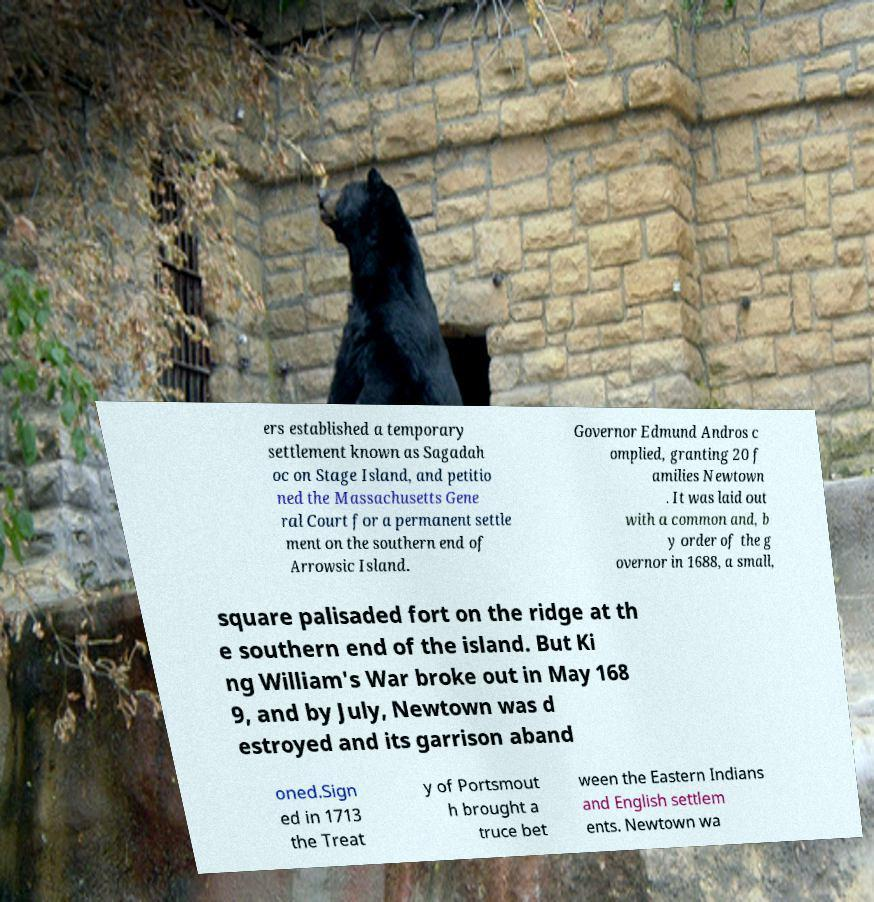For documentation purposes, I need the text within this image transcribed. Could you provide that? ers established a temporary settlement known as Sagadah oc on Stage Island, and petitio ned the Massachusetts Gene ral Court for a permanent settle ment on the southern end of Arrowsic Island. Governor Edmund Andros c omplied, granting 20 f amilies Newtown . It was laid out with a common and, b y order of the g overnor in 1688, a small, square palisaded fort on the ridge at th e southern end of the island. But Ki ng William's War broke out in May 168 9, and by July, Newtown was d estroyed and its garrison aband oned.Sign ed in 1713 the Treat y of Portsmout h brought a truce bet ween the Eastern Indians and English settlem ents. Newtown wa 